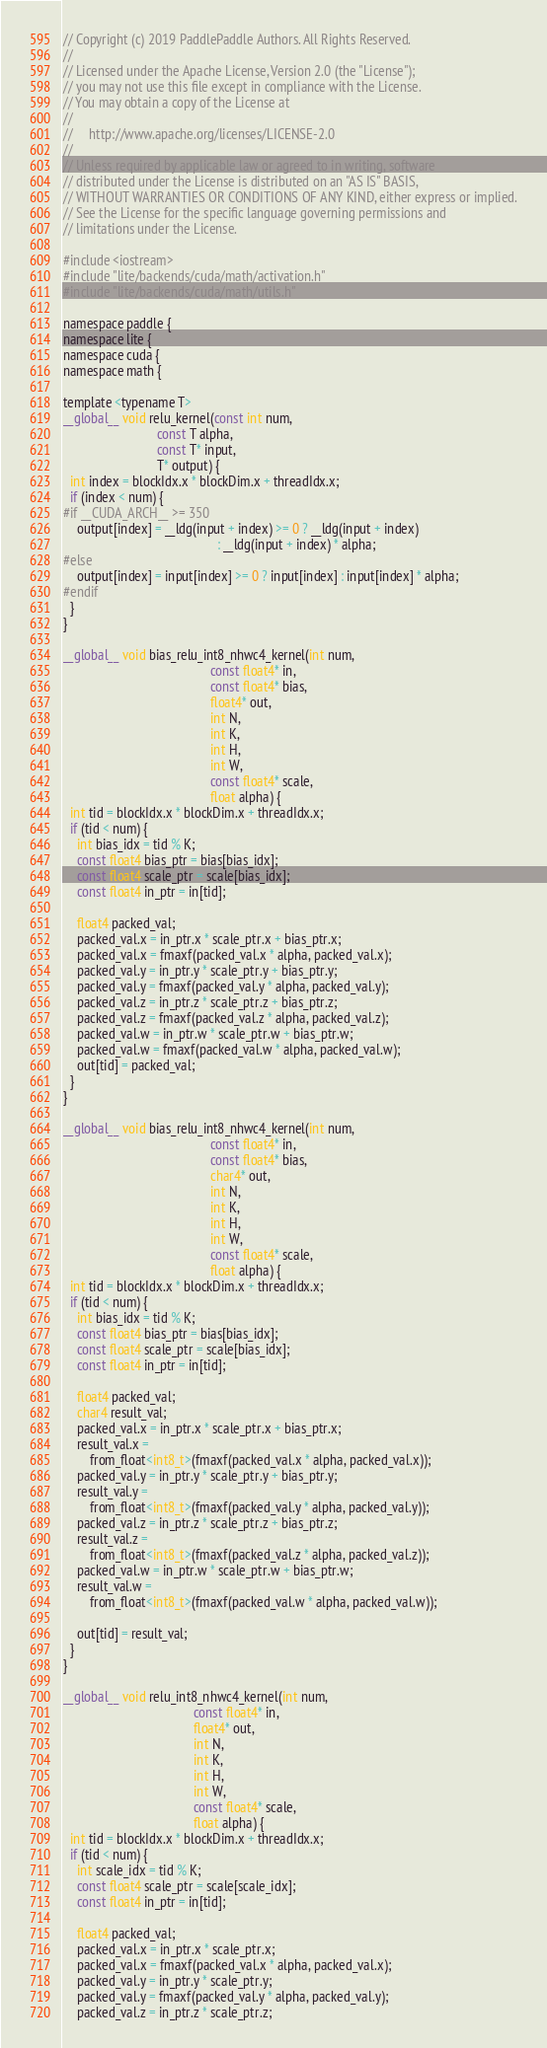Convert code to text. <code><loc_0><loc_0><loc_500><loc_500><_Cuda_>// Copyright (c) 2019 PaddlePaddle Authors. All Rights Reserved.
//
// Licensed under the Apache License, Version 2.0 (the "License");
// you may not use this file except in compliance with the License.
// You may obtain a copy of the License at
//
//     http://www.apache.org/licenses/LICENSE-2.0
//
// Unless required by applicable law or agreed to in writing, software
// distributed under the License is distributed on an "AS IS" BASIS,
// WITHOUT WARRANTIES OR CONDITIONS OF ANY KIND, either express or implied.
// See the License for the specific language governing permissions and
// limitations under the License.

#include <iostream>
#include "lite/backends/cuda/math/activation.h"
#include "lite/backends/cuda/math/utils.h"

namespace paddle {
namespace lite {
namespace cuda {
namespace math {

template <typename T>
__global__ void relu_kernel(const int num,
                            const T alpha,
                            const T* input,
                            T* output) {
  int index = blockIdx.x * blockDim.x + threadIdx.x;
  if (index < num) {
#if __CUDA_ARCH__ >= 350
    output[index] = __ldg(input + index) >= 0 ? __ldg(input + index)
                                              : __ldg(input + index) * alpha;
#else
    output[index] = input[index] >= 0 ? input[index] : input[index] * alpha;
#endif
  }
}

__global__ void bias_relu_int8_nhwc4_kernel(int num,
                                            const float4* in,
                                            const float4* bias,
                                            float4* out,
                                            int N,
                                            int K,
                                            int H,
                                            int W,
                                            const float4* scale,
                                            float alpha) {
  int tid = blockIdx.x * blockDim.x + threadIdx.x;
  if (tid < num) {
    int bias_idx = tid % K;
    const float4 bias_ptr = bias[bias_idx];
    const float4 scale_ptr = scale[bias_idx];
    const float4 in_ptr = in[tid];

    float4 packed_val;
    packed_val.x = in_ptr.x * scale_ptr.x + bias_ptr.x;
    packed_val.x = fmaxf(packed_val.x * alpha, packed_val.x);
    packed_val.y = in_ptr.y * scale_ptr.y + bias_ptr.y;
    packed_val.y = fmaxf(packed_val.y * alpha, packed_val.y);
    packed_val.z = in_ptr.z * scale_ptr.z + bias_ptr.z;
    packed_val.z = fmaxf(packed_val.z * alpha, packed_val.z);
    packed_val.w = in_ptr.w * scale_ptr.w + bias_ptr.w;
    packed_val.w = fmaxf(packed_val.w * alpha, packed_val.w);
    out[tid] = packed_val;
  }
}

__global__ void bias_relu_int8_nhwc4_kernel(int num,
                                            const float4* in,
                                            const float4* bias,
                                            char4* out,
                                            int N,
                                            int K,
                                            int H,
                                            int W,
                                            const float4* scale,
                                            float alpha) {
  int tid = blockIdx.x * blockDim.x + threadIdx.x;
  if (tid < num) {
    int bias_idx = tid % K;
    const float4 bias_ptr = bias[bias_idx];
    const float4 scale_ptr = scale[bias_idx];
    const float4 in_ptr = in[tid];

    float4 packed_val;
    char4 result_val;
    packed_val.x = in_ptr.x * scale_ptr.x + bias_ptr.x;
    result_val.x =
        from_float<int8_t>(fmaxf(packed_val.x * alpha, packed_val.x));
    packed_val.y = in_ptr.y * scale_ptr.y + bias_ptr.y;
    result_val.y =
        from_float<int8_t>(fmaxf(packed_val.y * alpha, packed_val.y));
    packed_val.z = in_ptr.z * scale_ptr.z + bias_ptr.z;
    result_val.z =
        from_float<int8_t>(fmaxf(packed_val.z * alpha, packed_val.z));
    packed_val.w = in_ptr.w * scale_ptr.w + bias_ptr.w;
    result_val.w =
        from_float<int8_t>(fmaxf(packed_val.w * alpha, packed_val.w));

    out[tid] = result_val;
  }
}

__global__ void relu_int8_nhwc4_kernel(int num,
                                       const float4* in,
                                       float4* out,
                                       int N,
                                       int K,
                                       int H,
                                       int W,
                                       const float4* scale,
                                       float alpha) {
  int tid = blockIdx.x * blockDim.x + threadIdx.x;
  if (tid < num) {
    int scale_idx = tid % K;
    const float4 scale_ptr = scale[scale_idx];
    const float4 in_ptr = in[tid];

    float4 packed_val;
    packed_val.x = in_ptr.x * scale_ptr.x;
    packed_val.x = fmaxf(packed_val.x * alpha, packed_val.x);
    packed_val.y = in_ptr.y * scale_ptr.y;
    packed_val.y = fmaxf(packed_val.y * alpha, packed_val.y);
    packed_val.z = in_ptr.z * scale_ptr.z;</code> 